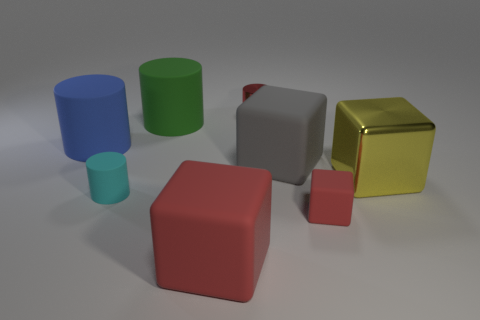What is the size of the cyan cylinder that is the same material as the large blue thing?
Keep it short and to the point. Small. Does the green rubber thing have the same shape as the small thing that is behind the green cylinder?
Ensure brevity in your answer.  Yes. Are there the same number of tiny shiny objects behind the small red shiny object and small cylinders that are on the left side of the green rubber thing?
Your answer should be very brief. No. There is a big rubber object that is the same color as the small shiny thing; what is its shape?
Your response must be concise. Cube. Does the tiny cylinder in front of the big green thing have the same color as the big block that is to the left of the red metallic thing?
Make the answer very short. No. Is the number of small red cylinders right of the gray thing greater than the number of large blue rubber cylinders?
Provide a succinct answer. No. What is the material of the large gray block?
Your answer should be very brief. Rubber. What shape is the small object that is made of the same material as the large yellow block?
Offer a very short reply. Cylinder. There is a gray cube that is to the right of the tiny red thing that is behind the tiny cyan cylinder; how big is it?
Make the answer very short. Large. There is a small cylinder that is in front of the red metallic thing; what color is it?
Your answer should be compact. Cyan. 